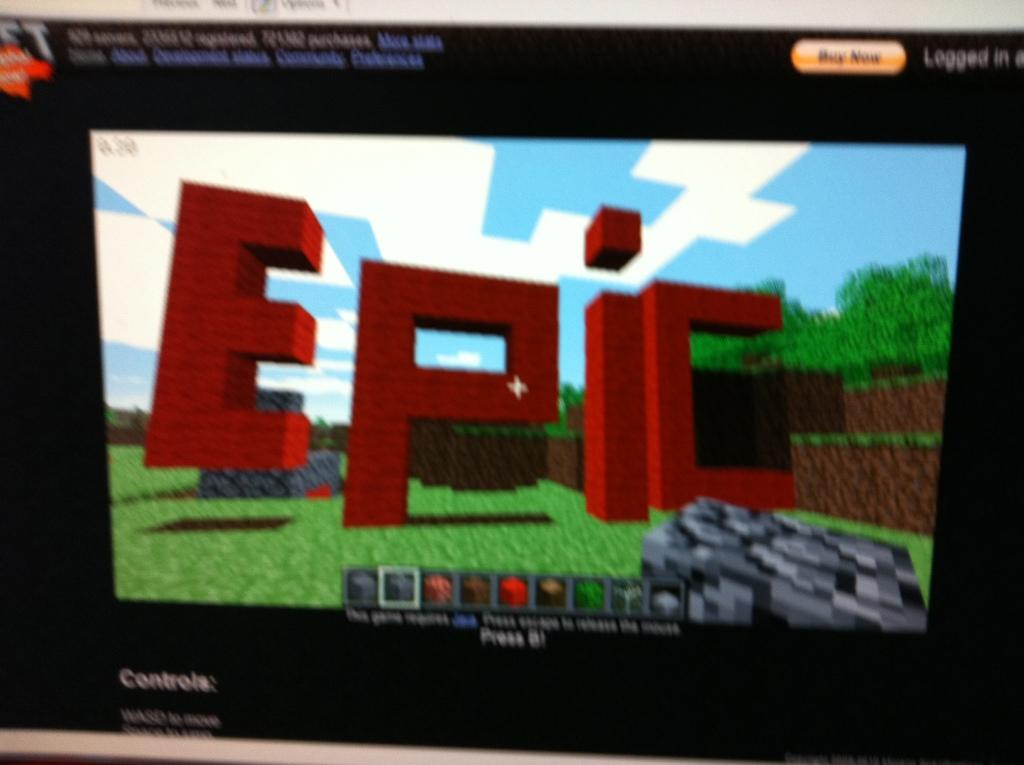<image>
Give a short and clear explanation of the subsequent image. A screen shot of a video game with the word EPIC on it 